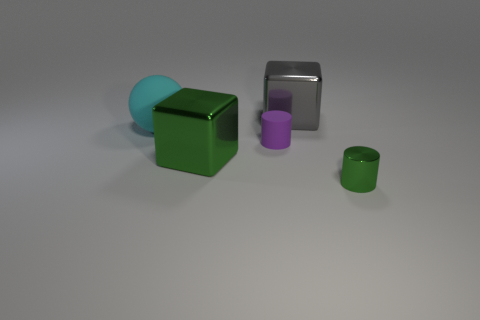There is a large cube that is in front of the big gray thing; does it have the same color as the cylinder in front of the big green block?
Make the answer very short. Yes. What shape is the large shiny object that is the same color as the small metal object?
Offer a terse response. Cube. Do the tiny shiny cylinder and the large rubber object have the same color?
Keep it short and to the point. No. How many small objects are rubber balls or rubber objects?
Give a very brief answer. 1. Are there any other things that are the same color as the large rubber thing?
Your answer should be compact. No. The large green thing that is made of the same material as the big gray thing is what shape?
Offer a terse response. Cube. There is a green object to the left of the tiny metallic cylinder; what size is it?
Keep it short and to the point. Large. The big gray metal object is what shape?
Your answer should be compact. Cube. Does the green object in front of the big green shiny cube have the same size as the green thing on the left side of the small purple rubber cylinder?
Your answer should be compact. No. What size is the thing that is on the right side of the cube behind the tiny thing on the left side of the large gray thing?
Your answer should be compact. Small. 